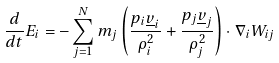Convert formula to latex. <formula><loc_0><loc_0><loc_500><loc_500>\frac { d } { d t } E _ { i } = - \sum _ { j = 1 } ^ { N } m _ { j } \left ( \frac { p _ { i } \underline { v } _ { i } } { \rho _ { i } ^ { 2 } } + \frac { p _ { j } \underline { v } _ { j } } { \rho _ { j } ^ { 2 } } \right ) \cdot \nabla _ { i } W _ { i j }</formula> 